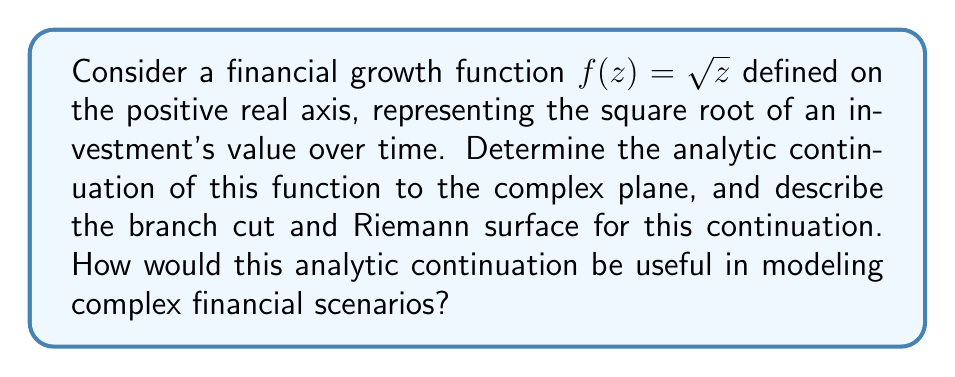What is the answer to this math problem? To determine the analytic continuation of $f(z) = \sqrt{z}$ to the complex plane, we need to consider the following steps:

1) The function $f(z) = \sqrt{z}$ is initially defined on the positive real axis. However, it can be extended to a multi-valued function on the complex plane.

2) We can express the square root in polar form:

   For $z = re^{i\theta}$, $\sqrt{z} = \sqrt{r}e^{i\theta/2}$

3) The principal branch of the square root function is defined as:

   $$f(z) = \sqrt{r}e^{i\theta/2}, \quad -\pi < \theta \leq \pi$$

4) This creates a branch cut along the negative real axis. The branch cut is necessary because the function is not continuous when we make a full rotation around the origin.

5) To visualize this, we can construct a Riemann surface. The Riemann surface for the square root function consists of two sheets:

   Sheet 1: $\sqrt{r}e^{i\theta/2}$, $-\pi < \theta \leq \pi$
   Sheet 2: $-\sqrt{r}e^{i\theta/2}$, $-\pi < \theta \leq \pi$

6) These sheets are connected along the branch cut (negative real axis). When we cross the branch cut, we move from one sheet to the other.

7) The analytic continuation allows us to define the square root function continuously on this two-sheeted Riemann surface.

In financial modeling, this analytic continuation can be useful in several ways:

a) It allows for the modeling of complex financial scenarios where the input (investment value) may become negative or complex.

b) The two sheets of the Riemann surface could represent different states of the market or economy, with the branch cut representing a critical threshold or transition point.

c) The multi-valued nature of the function on the complex plane can be used to model scenarios with multiple possible outcomes or states.

d) The behavior around the branch point (origin) could represent critical points in financial systems where small changes can lead to significantly different outcomes.
Answer: The analytic continuation of $f(z) = \sqrt{z}$ to the complex plane is a two-valued function defined on a two-sheeted Riemann surface. The principal branch is given by $f(z) = \sqrt{r}e^{i\theta/2}$ for $-\pi < \theta \leq \pi$, with a branch cut along the negative real axis. This continuation allows for more comprehensive financial modeling, including scenarios with negative or complex inputs, multiple market states, and critical transition points. 